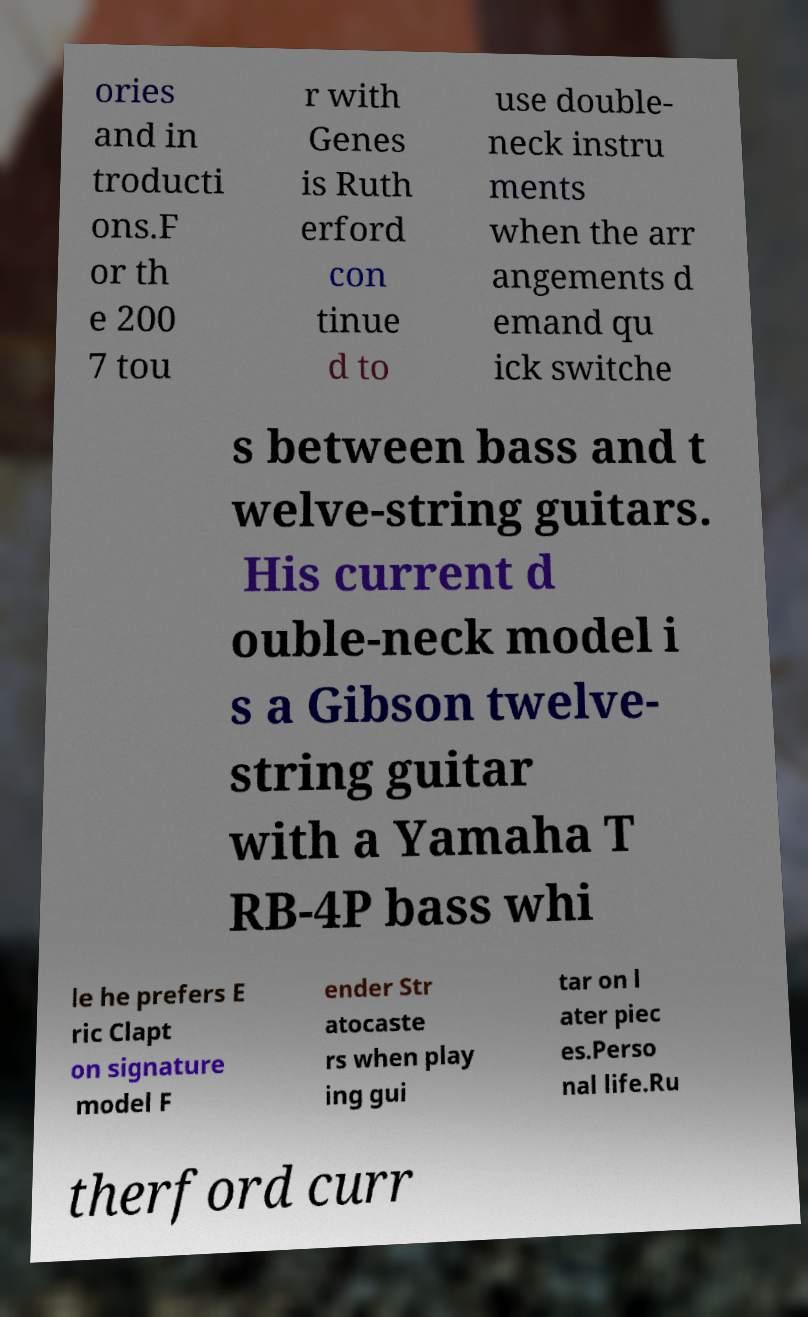Please read and relay the text visible in this image. What does it say? ories and in troducti ons.F or th e 200 7 tou r with Genes is Ruth erford con tinue d to use double- neck instru ments when the arr angements d emand qu ick switche s between bass and t welve-string guitars. His current d ouble-neck model i s a Gibson twelve- string guitar with a Yamaha T RB-4P bass whi le he prefers E ric Clapt on signature model F ender Str atocaste rs when play ing gui tar on l ater piec es.Perso nal life.Ru therford curr 